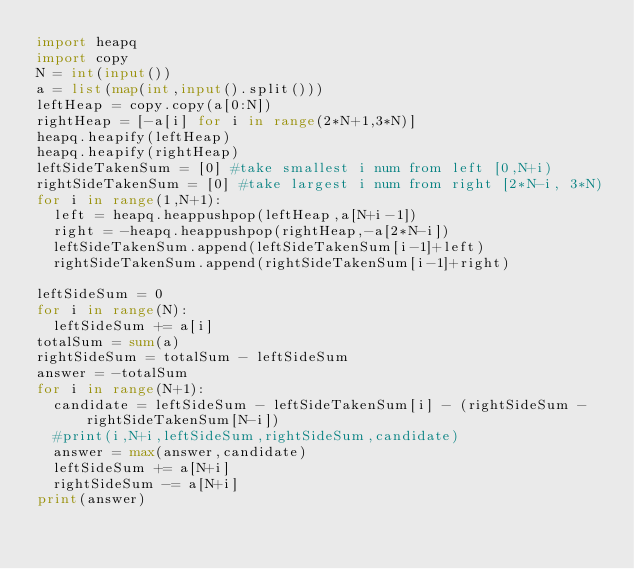Convert code to text. <code><loc_0><loc_0><loc_500><loc_500><_Python_>import heapq
import copy
N = int(input())
a = list(map(int,input().split()))
leftHeap = copy.copy(a[0:N])
rightHeap = [-a[i] for i in range(2*N+1,3*N)]
heapq.heapify(leftHeap)
heapq.heapify(rightHeap)
leftSideTakenSum = [0] #take smallest i num from left [0,N+i) 
rightSideTakenSum = [0] #take largest i num from right [2*N-i, 3*N)
for i in range(1,N+1):
  left = heapq.heappushpop(leftHeap,a[N+i-1])
  right = -heapq.heappushpop(rightHeap,-a[2*N-i])
  leftSideTakenSum.append(leftSideTakenSum[i-1]+left)
  rightSideTakenSum.append(rightSideTakenSum[i-1]+right)

leftSideSum = 0
for i in range(N):
  leftSideSum += a[i]
totalSum = sum(a)
rightSideSum = totalSum - leftSideSum
answer = -totalSum
for i in range(N+1):
  candidate = leftSideSum - leftSideTakenSum[i] - (rightSideSum - rightSideTakenSum[N-i])
  #print(i,N+i,leftSideSum,rightSideSum,candidate)
  answer = max(answer,candidate)
  leftSideSum += a[N+i]
  rightSideSum -= a[N+i]
print(answer)</code> 